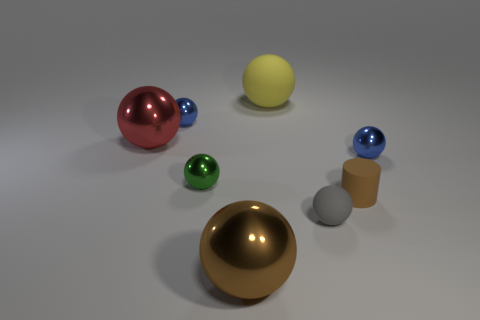There is a shiny object that is the same color as the cylinder; what shape is it?
Make the answer very short. Sphere. What is the size of the gray sphere that is made of the same material as the yellow thing?
Make the answer very short. Small. Is there any other thing that has the same color as the small rubber cylinder?
Offer a very short reply. Yes. There is a ball in front of the rubber ball in front of the tiny shiny object right of the small brown matte object; what is its material?
Ensure brevity in your answer.  Metal. What number of rubber objects are tiny things or green objects?
Make the answer very short. 2. Is the rubber cylinder the same color as the large rubber thing?
Your answer should be very brief. No. What number of things are small brown objects or large balls on the right side of the large red metal ball?
Provide a short and direct response. 3. There is a blue metal thing on the right side of the rubber cylinder; is it the same size as the tiny matte sphere?
Your answer should be very brief. Yes. How many other things are the same shape as the gray object?
Provide a succinct answer. 6. How many gray things are tiny metallic things or small rubber blocks?
Make the answer very short. 0. 